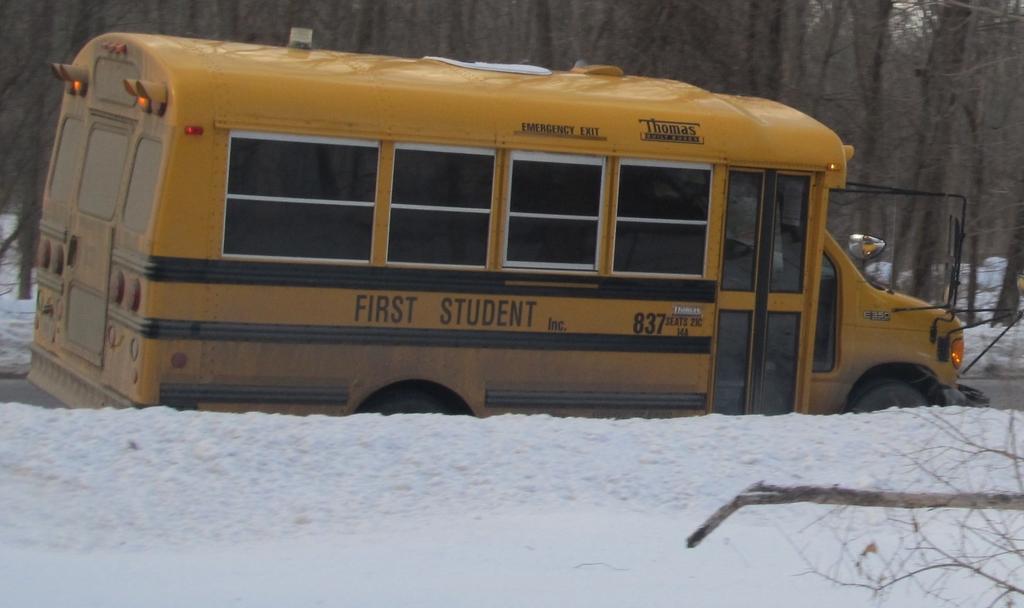What is the bus number?
Provide a succinct answer. 837. What is this vehicle called?
Your answer should be very brief. Bus. 